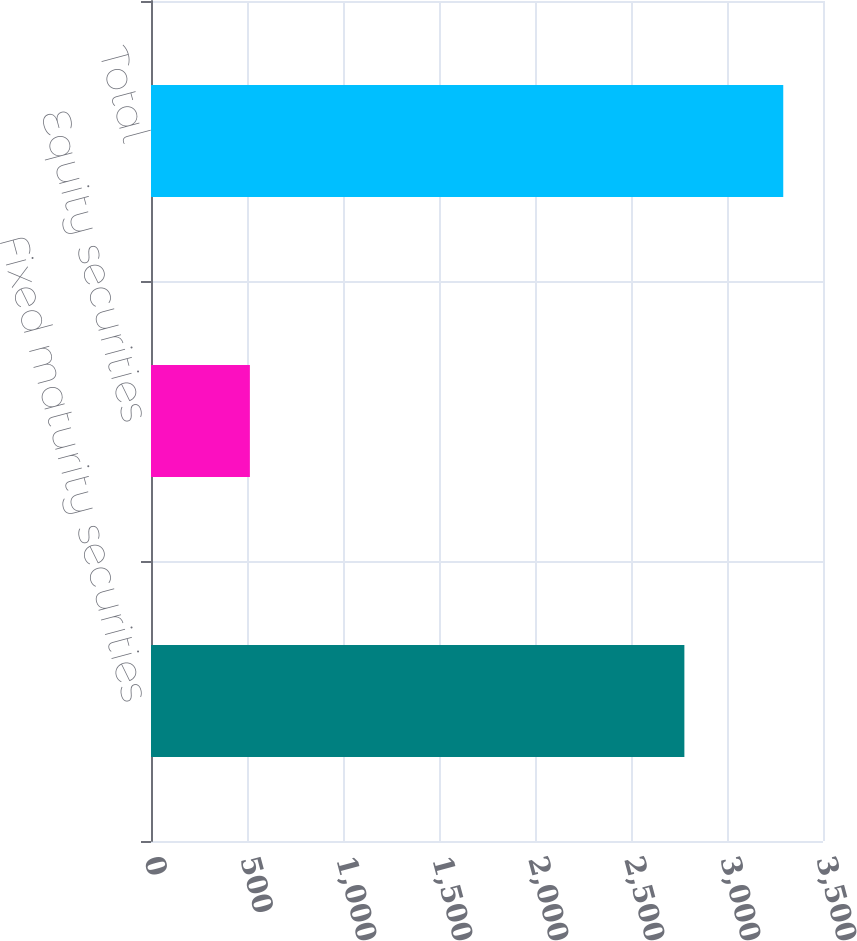<chart> <loc_0><loc_0><loc_500><loc_500><bar_chart><fcel>Fixed maturity securities<fcel>Equity securities<fcel>Total<nl><fcel>2778<fcel>515<fcel>3293<nl></chart> 